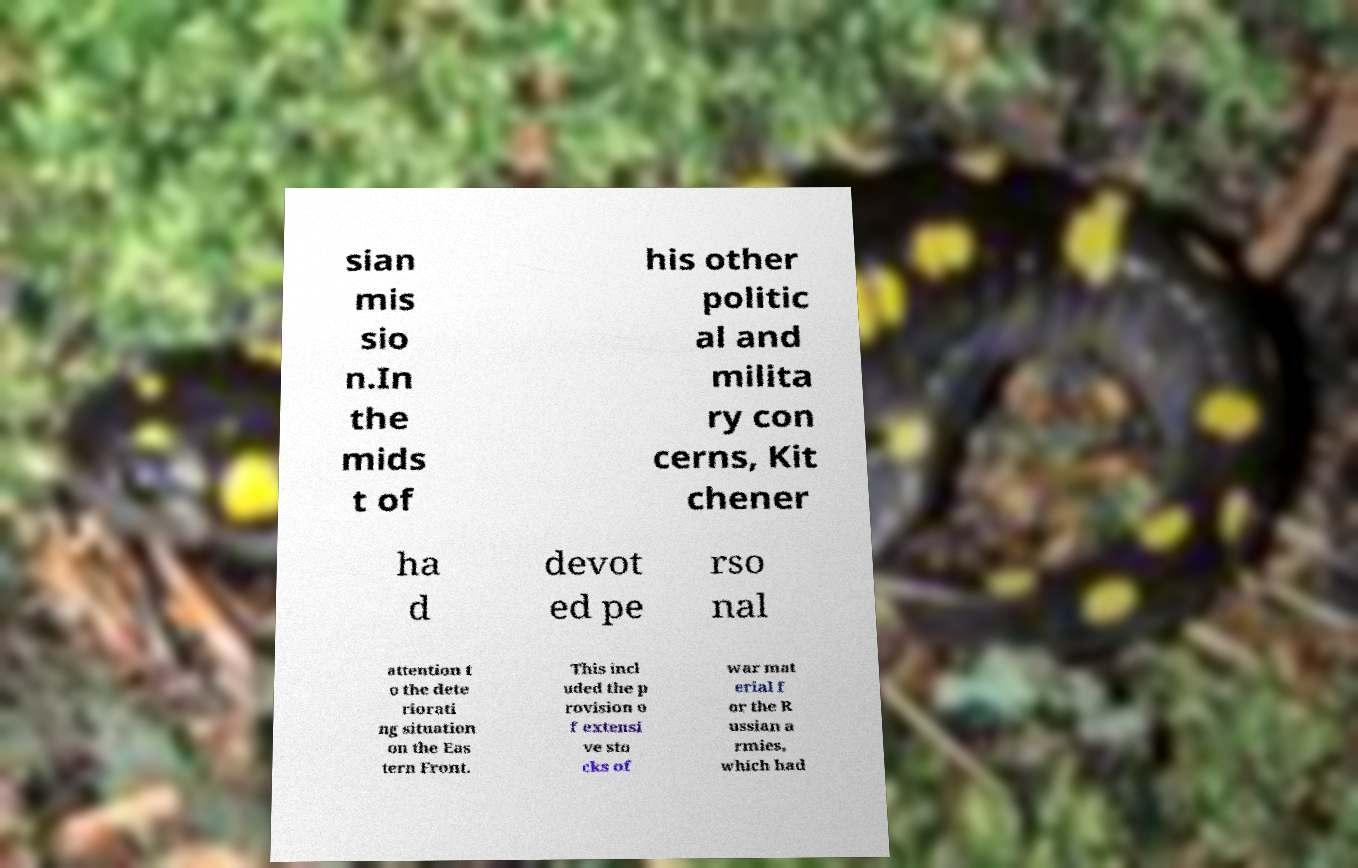I need the written content from this picture converted into text. Can you do that? sian mis sio n.In the mids t of his other politic al and milita ry con cerns, Kit chener ha d devot ed pe rso nal attention t o the dete riorati ng situation on the Eas tern Front. This incl uded the p rovision o f extensi ve sto cks of war mat erial f or the R ussian a rmies, which had 